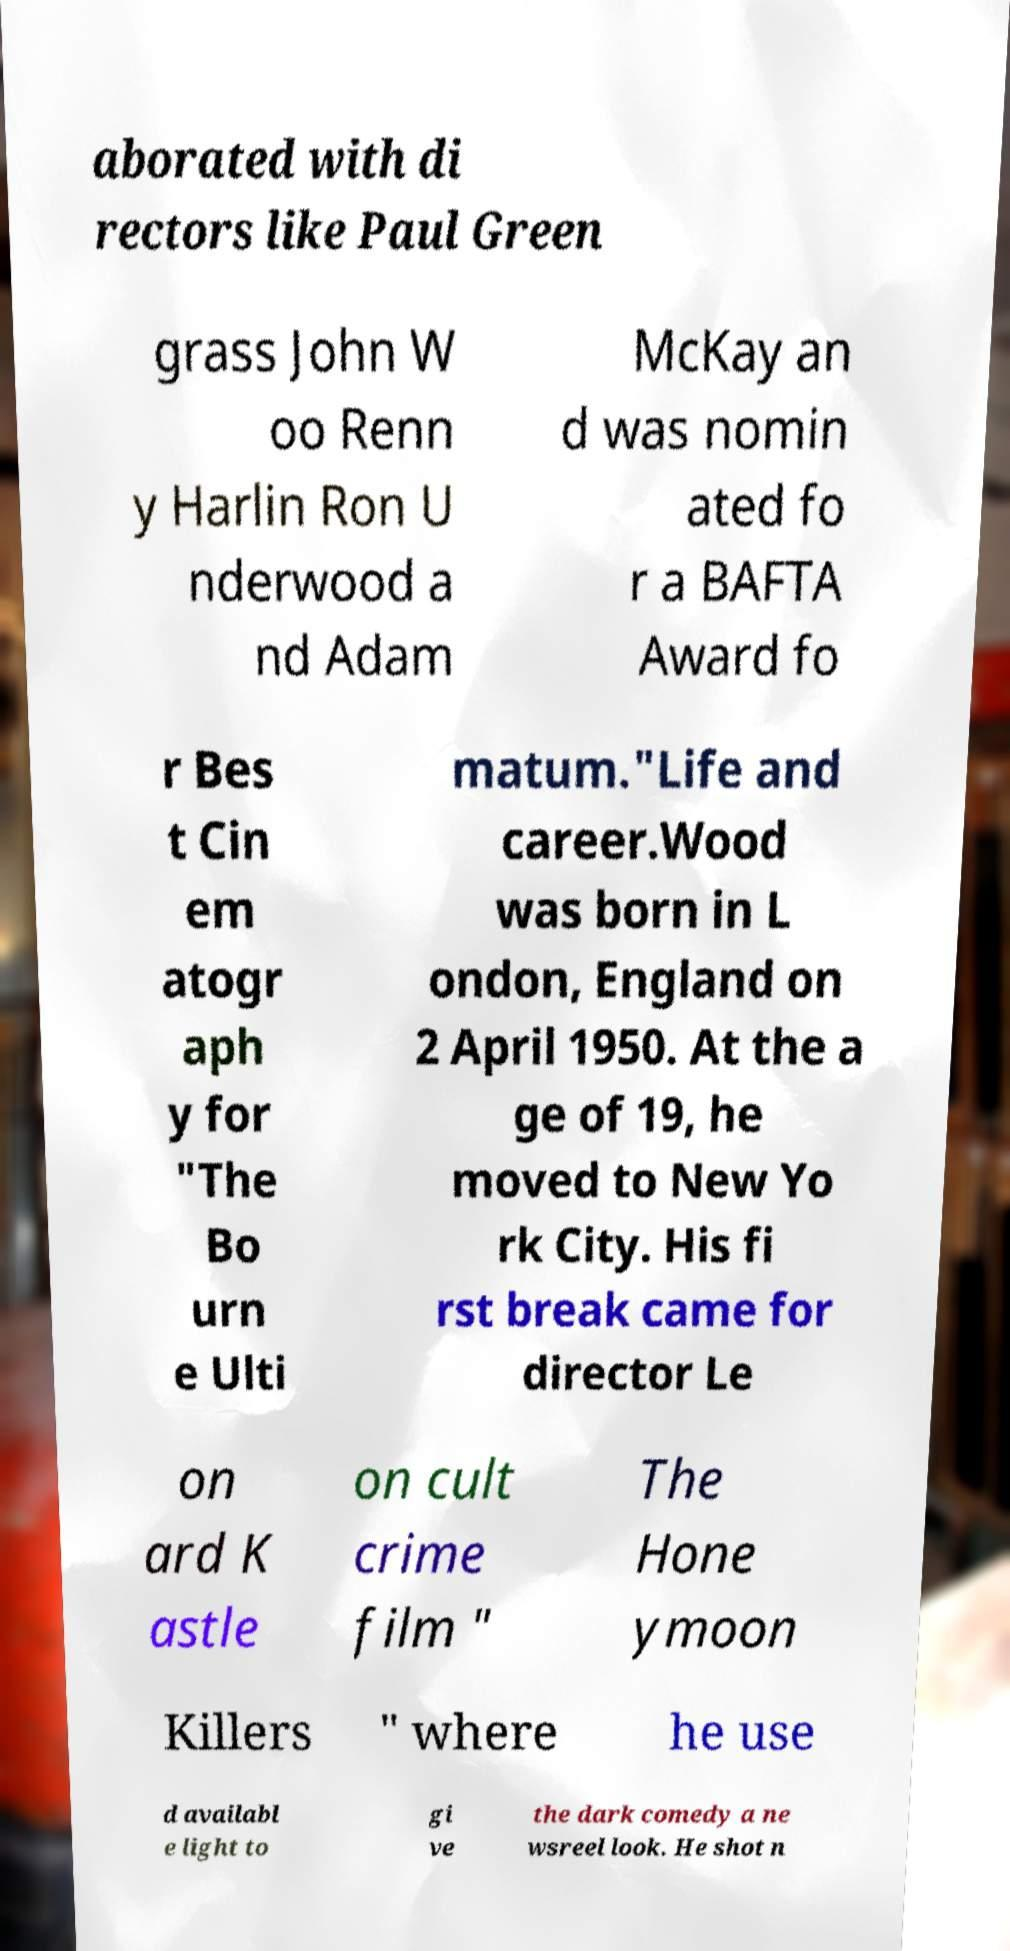For documentation purposes, I need the text within this image transcribed. Could you provide that? aborated with di rectors like Paul Green grass John W oo Renn y Harlin Ron U nderwood a nd Adam McKay an d was nomin ated fo r a BAFTA Award fo r Bes t Cin em atogr aph y for "The Bo urn e Ulti matum."Life and career.Wood was born in L ondon, England on 2 April 1950. At the a ge of 19, he moved to New Yo rk City. His fi rst break came for director Le on ard K astle on cult crime film " The Hone ymoon Killers " where he use d availabl e light to gi ve the dark comedy a ne wsreel look. He shot n 